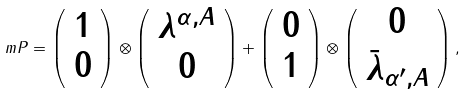Convert formula to latex. <formula><loc_0><loc_0><loc_500><loc_500>\ m P = \left ( \begin{array} { c } 1 \\ 0 \end{array} \right ) \otimes \left ( \begin{array} { c } \lambda ^ { \alpha , A } \\ 0 \end{array} \right ) + \left ( \begin{array} { c } 0 \\ 1 \end{array} \right ) \otimes \left ( \begin{array} { c } 0 \\ \bar { \lambda } _ { \alpha ^ { \prime } , A } \end{array} \right ) ,</formula> 